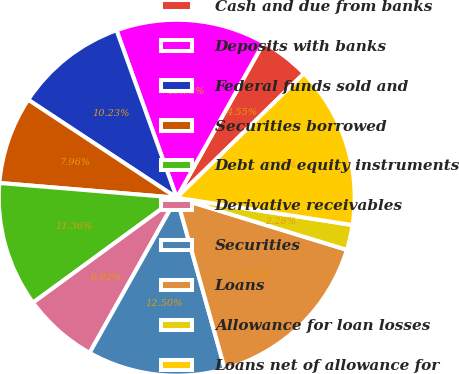<chart> <loc_0><loc_0><loc_500><loc_500><pie_chart><fcel>Cash and due from banks<fcel>Deposits with banks<fcel>Federal funds sold and<fcel>Securities borrowed<fcel>Debt and equity instruments<fcel>Derivative receivables<fcel>Securities<fcel>Loans<fcel>Allowance for loan losses<fcel>Loans net of allowance for<nl><fcel>4.55%<fcel>13.63%<fcel>10.23%<fcel>7.96%<fcel>11.36%<fcel>6.82%<fcel>12.5%<fcel>15.91%<fcel>2.28%<fcel>14.77%<nl></chart> 